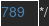<code> <loc_0><loc_0><loc_500><loc_500><_CSS_>*/</code> 